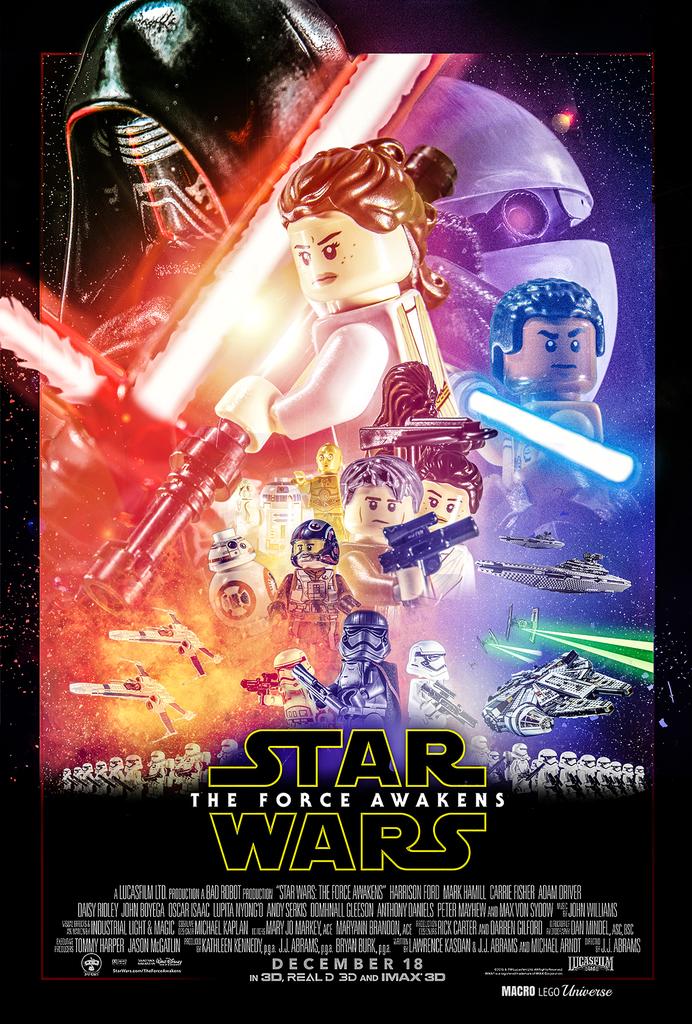When does this movie come out?
Offer a very short reply. December 18. What is the title of the movie advertised?
Your answer should be very brief. Star wars the force awakens. 